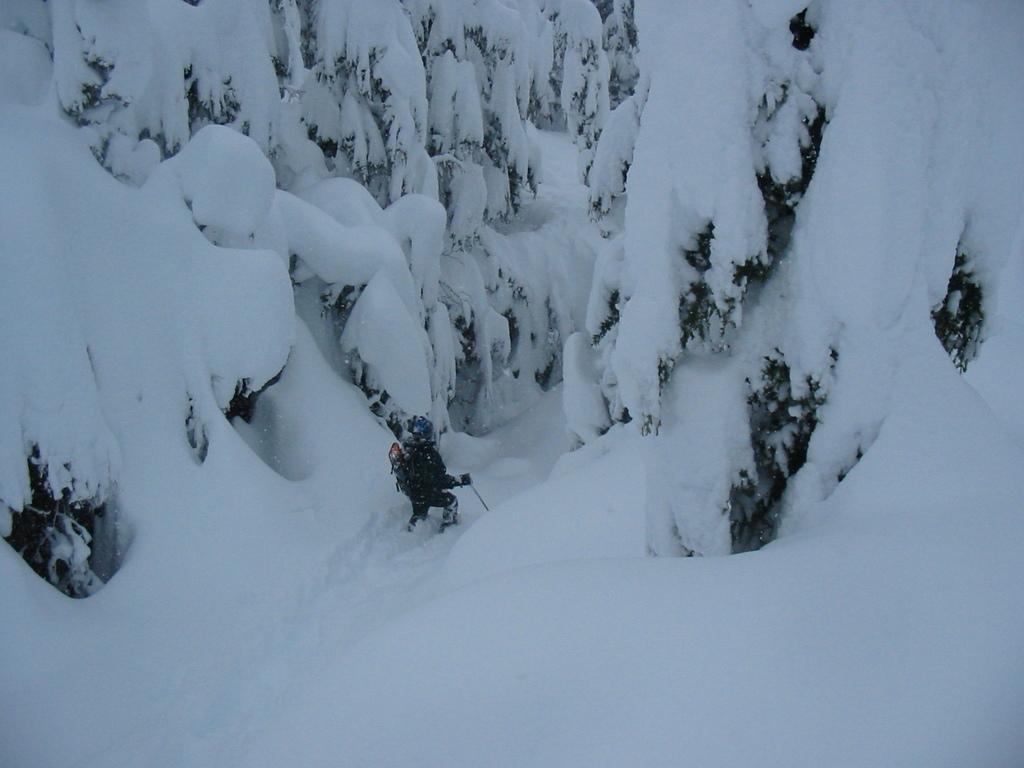Describe this image in one or two sentences. In this image, we can see trees are covered with snow. In the middle of the image, we can see a person is holding a stick. 